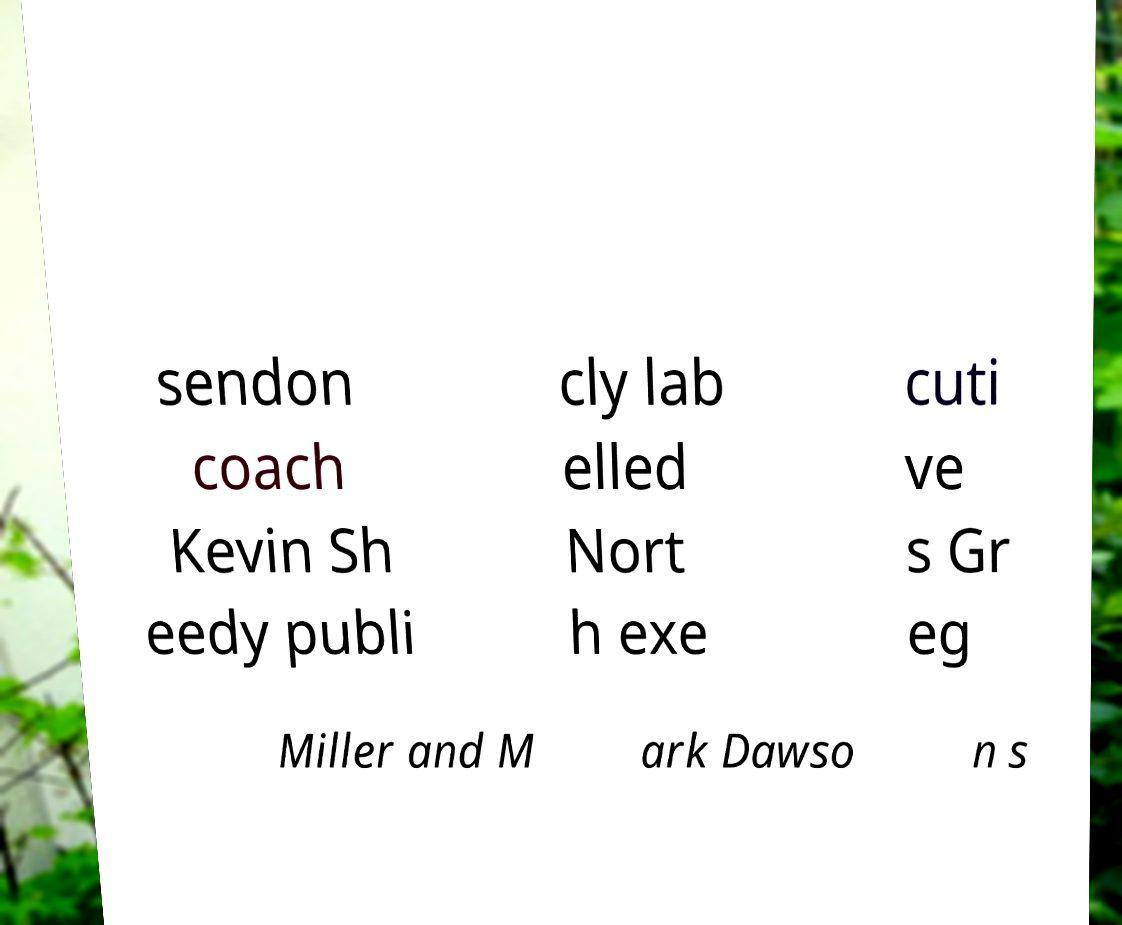Could you extract and type out the text from this image? sendon coach Kevin Sh eedy publi cly lab elled Nort h exe cuti ve s Gr eg Miller and M ark Dawso n s 